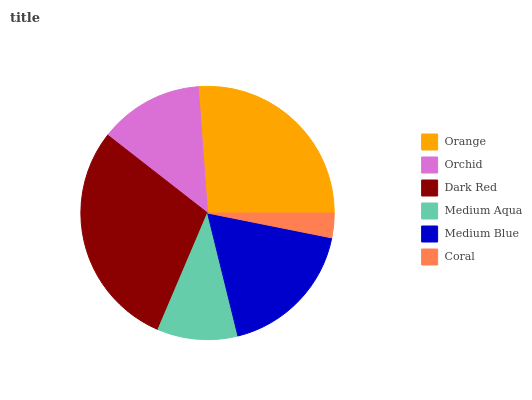Is Coral the minimum?
Answer yes or no. Yes. Is Dark Red the maximum?
Answer yes or no. Yes. Is Orchid the minimum?
Answer yes or no. No. Is Orchid the maximum?
Answer yes or no. No. Is Orange greater than Orchid?
Answer yes or no. Yes. Is Orchid less than Orange?
Answer yes or no. Yes. Is Orchid greater than Orange?
Answer yes or no. No. Is Orange less than Orchid?
Answer yes or no. No. Is Medium Blue the high median?
Answer yes or no. Yes. Is Orchid the low median?
Answer yes or no. Yes. Is Orange the high median?
Answer yes or no. No. Is Coral the low median?
Answer yes or no. No. 